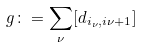<formula> <loc_0><loc_0><loc_500><loc_500>g \colon = \sum _ { \nu } [ d _ { i _ { \nu } , i { \nu + 1 } } ]</formula> 